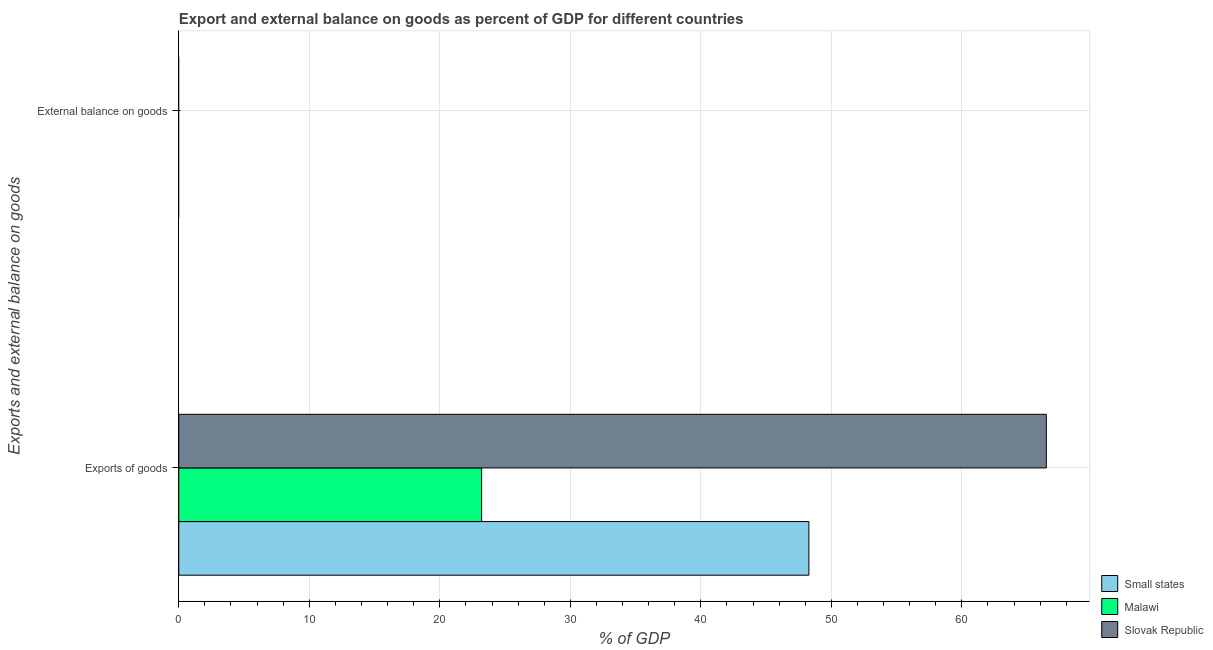How many different coloured bars are there?
Your answer should be very brief. 3. Are the number of bars per tick equal to the number of legend labels?
Your answer should be compact. No. What is the label of the 2nd group of bars from the top?
Provide a succinct answer. Exports of goods. Across all countries, what is the maximum export of goods as percentage of gdp?
Your response must be concise. 66.47. Across all countries, what is the minimum export of goods as percentage of gdp?
Offer a terse response. 23.21. In which country was the export of goods as percentage of gdp maximum?
Provide a succinct answer. Slovak Republic. What is the total export of goods as percentage of gdp in the graph?
Provide a short and direct response. 137.96. What is the difference between the export of goods as percentage of gdp in Small states and that in Malawi?
Offer a very short reply. 25.07. What is the difference between the external balance on goods as percentage of gdp in Malawi and the export of goods as percentage of gdp in Slovak Republic?
Give a very brief answer. -66.47. What is the average export of goods as percentage of gdp per country?
Make the answer very short. 45.99. What is the ratio of the export of goods as percentage of gdp in Malawi to that in Small states?
Your answer should be compact. 0.48. In how many countries, is the external balance on goods as percentage of gdp greater than the average external balance on goods as percentage of gdp taken over all countries?
Keep it short and to the point. 0. How many bars are there?
Your answer should be very brief. 3. Are all the bars in the graph horizontal?
Offer a very short reply. Yes. How many countries are there in the graph?
Provide a short and direct response. 3. What is the difference between two consecutive major ticks on the X-axis?
Ensure brevity in your answer.  10. Are the values on the major ticks of X-axis written in scientific E-notation?
Provide a succinct answer. No. Does the graph contain any zero values?
Provide a short and direct response. Yes. Does the graph contain grids?
Your response must be concise. Yes. How many legend labels are there?
Offer a terse response. 3. How are the legend labels stacked?
Give a very brief answer. Vertical. What is the title of the graph?
Make the answer very short. Export and external balance on goods as percent of GDP for different countries. Does "Algeria" appear as one of the legend labels in the graph?
Your response must be concise. No. What is the label or title of the X-axis?
Provide a succinct answer. % of GDP. What is the label or title of the Y-axis?
Keep it short and to the point. Exports and external balance on goods. What is the % of GDP in Small states in Exports of goods?
Offer a very short reply. 48.28. What is the % of GDP in Malawi in Exports of goods?
Keep it short and to the point. 23.21. What is the % of GDP of Slovak Republic in Exports of goods?
Provide a short and direct response. 66.47. What is the % of GDP of Small states in External balance on goods?
Your response must be concise. 0. Across all Exports and external balance on goods, what is the maximum % of GDP in Small states?
Provide a short and direct response. 48.28. Across all Exports and external balance on goods, what is the maximum % of GDP of Malawi?
Give a very brief answer. 23.21. Across all Exports and external balance on goods, what is the maximum % of GDP in Slovak Republic?
Offer a very short reply. 66.47. Across all Exports and external balance on goods, what is the minimum % of GDP of Small states?
Provide a short and direct response. 0. What is the total % of GDP of Small states in the graph?
Your answer should be compact. 48.28. What is the total % of GDP in Malawi in the graph?
Your response must be concise. 23.21. What is the total % of GDP of Slovak Republic in the graph?
Ensure brevity in your answer.  66.47. What is the average % of GDP in Small states per Exports and external balance on goods?
Ensure brevity in your answer.  24.14. What is the average % of GDP in Malawi per Exports and external balance on goods?
Make the answer very short. 11.6. What is the average % of GDP of Slovak Republic per Exports and external balance on goods?
Make the answer very short. 33.24. What is the difference between the % of GDP in Small states and % of GDP in Malawi in Exports of goods?
Make the answer very short. 25.07. What is the difference between the % of GDP of Small states and % of GDP of Slovak Republic in Exports of goods?
Ensure brevity in your answer.  -18.19. What is the difference between the % of GDP of Malawi and % of GDP of Slovak Republic in Exports of goods?
Offer a very short reply. -43.27. What is the difference between the highest and the lowest % of GDP in Small states?
Provide a succinct answer. 48.28. What is the difference between the highest and the lowest % of GDP of Malawi?
Your answer should be very brief. 23.21. What is the difference between the highest and the lowest % of GDP in Slovak Republic?
Your answer should be compact. 66.47. 